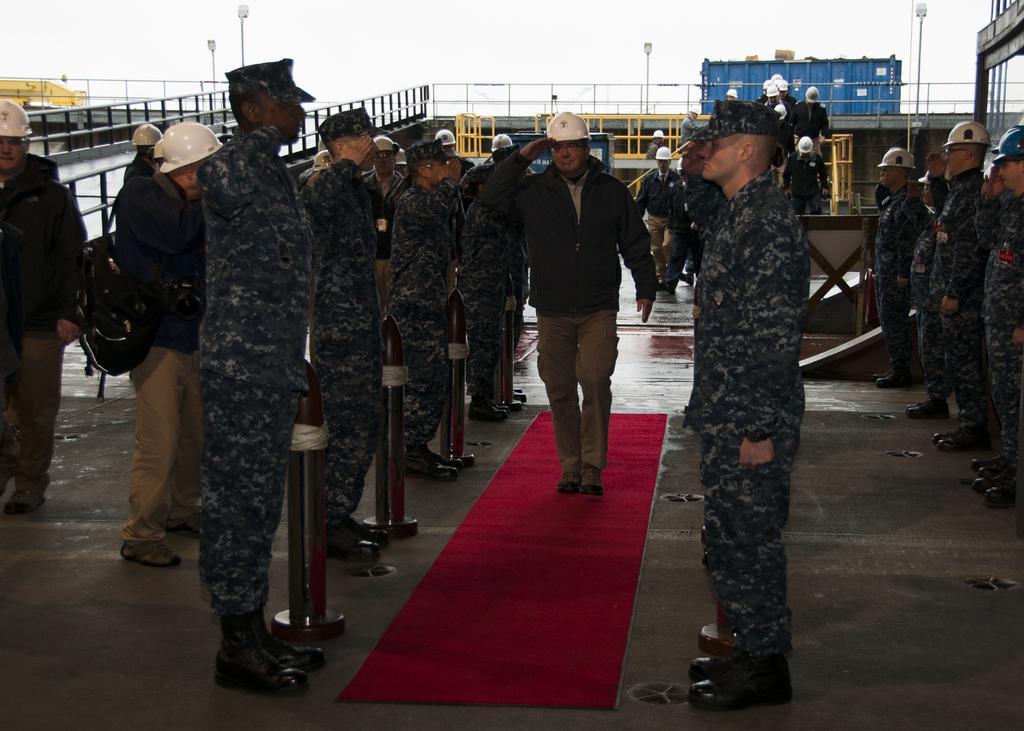How would you summarize this image in a sentence or two? In this image we can see there are people standing and saluting each other and the other person walking on the mat and saluting. At the back we can see the bridge, railing, container, barricades, light poles and the sky. 